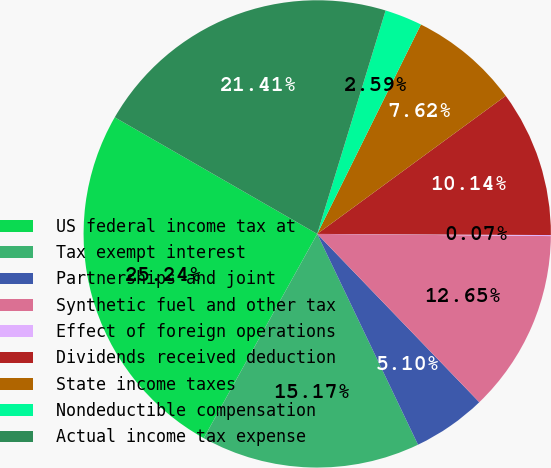Convert chart. <chart><loc_0><loc_0><loc_500><loc_500><pie_chart><fcel>US federal income tax at<fcel>Tax exempt interest<fcel>Partnerships and joint<fcel>Synthetic fuel and other tax<fcel>Effect of foreign operations<fcel>Dividends received deduction<fcel>State income taxes<fcel>Nondeductible compensation<fcel>Actual income tax expense<nl><fcel>25.24%<fcel>15.17%<fcel>5.1%<fcel>12.65%<fcel>0.07%<fcel>10.14%<fcel>7.62%<fcel>2.59%<fcel>21.41%<nl></chart> 